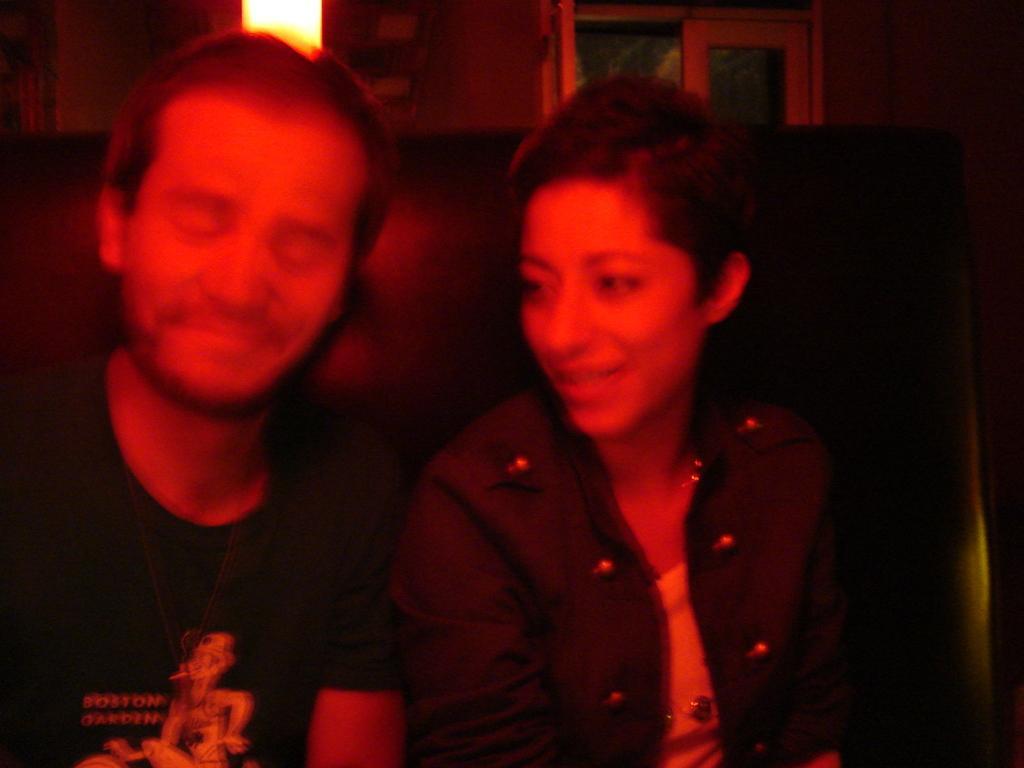Describe this image in one or two sentences. In this image, we can see people sitting on the couch and in the background, there is a light and we can see windows. 